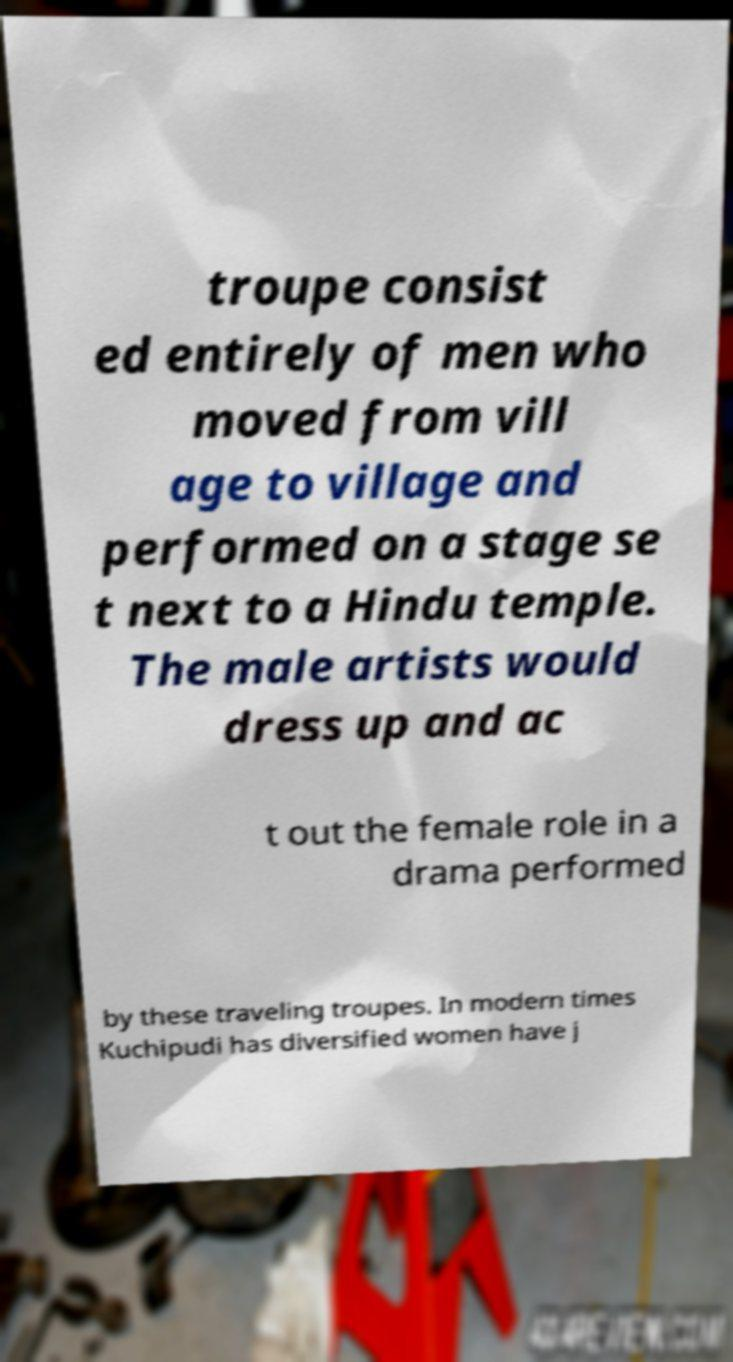I need the written content from this picture converted into text. Can you do that? troupe consist ed entirely of men who moved from vill age to village and performed on a stage se t next to a Hindu temple. The male artists would dress up and ac t out the female role in a drama performed by these traveling troupes. In modern times Kuchipudi has diversified women have j 